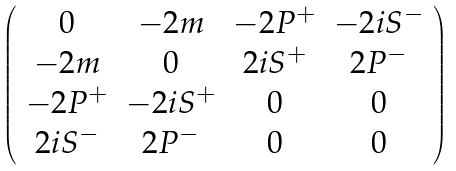<formula> <loc_0><loc_0><loc_500><loc_500>\left ( \begin{array} { c c c c } 0 & - 2 m & - 2 P ^ { + } & - 2 i S ^ { - } \\ - 2 m & 0 & 2 i S ^ { + } & 2 P ^ { - } \\ - 2 P ^ { + } & - 2 i S ^ { + } & 0 & 0 \\ 2 i S ^ { - } & 2 P ^ { - } & 0 & 0 \end{array} \right )</formula> 